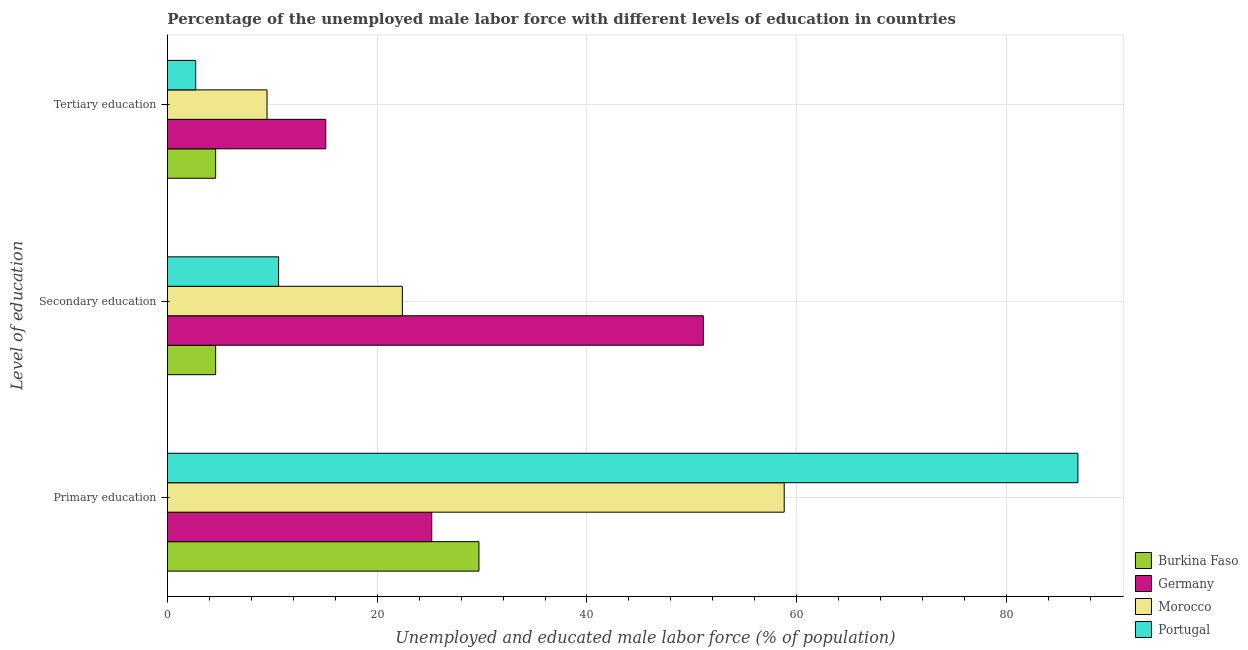How many different coloured bars are there?
Make the answer very short. 4. How many groups of bars are there?
Give a very brief answer. 3. Are the number of bars per tick equal to the number of legend labels?
Your response must be concise. Yes. How many bars are there on the 3rd tick from the top?
Your response must be concise. 4. How many bars are there on the 3rd tick from the bottom?
Your answer should be very brief. 4. What is the label of the 1st group of bars from the top?
Keep it short and to the point. Tertiary education. What is the percentage of male labor force who received tertiary education in Germany?
Provide a succinct answer. 15.1. Across all countries, what is the maximum percentage of male labor force who received primary education?
Make the answer very short. 86.8. Across all countries, what is the minimum percentage of male labor force who received secondary education?
Make the answer very short. 4.6. What is the total percentage of male labor force who received primary education in the graph?
Make the answer very short. 200.5. What is the difference between the percentage of male labor force who received secondary education in Burkina Faso and that in Portugal?
Make the answer very short. -6. What is the difference between the percentage of male labor force who received primary education in Germany and the percentage of male labor force who received secondary education in Burkina Faso?
Provide a short and direct response. 20.6. What is the average percentage of male labor force who received secondary education per country?
Provide a short and direct response. 22.17. What is the difference between the percentage of male labor force who received secondary education and percentage of male labor force who received primary education in Portugal?
Give a very brief answer. -76.2. In how many countries, is the percentage of male labor force who received primary education greater than 12 %?
Your answer should be very brief. 4. What is the ratio of the percentage of male labor force who received tertiary education in Portugal to that in Burkina Faso?
Offer a terse response. 0.59. What is the difference between the highest and the second highest percentage of male labor force who received tertiary education?
Offer a very short reply. 5.6. What is the difference between the highest and the lowest percentage of male labor force who received tertiary education?
Offer a terse response. 12.4. Is the sum of the percentage of male labor force who received secondary education in Burkina Faso and Morocco greater than the maximum percentage of male labor force who received tertiary education across all countries?
Your answer should be compact. Yes. What does the 1st bar from the bottom in Tertiary education represents?
Offer a very short reply. Burkina Faso. How many bars are there?
Make the answer very short. 12. How many countries are there in the graph?
Offer a terse response. 4. What is the difference between two consecutive major ticks on the X-axis?
Provide a short and direct response. 20. Where does the legend appear in the graph?
Offer a very short reply. Bottom right. How many legend labels are there?
Give a very brief answer. 4. What is the title of the graph?
Provide a short and direct response. Percentage of the unemployed male labor force with different levels of education in countries. What is the label or title of the X-axis?
Your response must be concise. Unemployed and educated male labor force (% of population). What is the label or title of the Y-axis?
Offer a very short reply. Level of education. What is the Unemployed and educated male labor force (% of population) in Burkina Faso in Primary education?
Offer a very short reply. 29.7. What is the Unemployed and educated male labor force (% of population) in Germany in Primary education?
Offer a terse response. 25.2. What is the Unemployed and educated male labor force (% of population) of Morocco in Primary education?
Give a very brief answer. 58.8. What is the Unemployed and educated male labor force (% of population) of Portugal in Primary education?
Offer a terse response. 86.8. What is the Unemployed and educated male labor force (% of population) of Burkina Faso in Secondary education?
Keep it short and to the point. 4.6. What is the Unemployed and educated male labor force (% of population) in Germany in Secondary education?
Ensure brevity in your answer.  51.1. What is the Unemployed and educated male labor force (% of population) in Morocco in Secondary education?
Make the answer very short. 22.4. What is the Unemployed and educated male labor force (% of population) in Portugal in Secondary education?
Give a very brief answer. 10.6. What is the Unemployed and educated male labor force (% of population) in Burkina Faso in Tertiary education?
Ensure brevity in your answer.  4.6. What is the Unemployed and educated male labor force (% of population) of Germany in Tertiary education?
Your answer should be compact. 15.1. What is the Unemployed and educated male labor force (% of population) of Portugal in Tertiary education?
Your response must be concise. 2.7. Across all Level of education, what is the maximum Unemployed and educated male labor force (% of population) in Burkina Faso?
Provide a succinct answer. 29.7. Across all Level of education, what is the maximum Unemployed and educated male labor force (% of population) of Germany?
Keep it short and to the point. 51.1. Across all Level of education, what is the maximum Unemployed and educated male labor force (% of population) of Morocco?
Your response must be concise. 58.8. Across all Level of education, what is the maximum Unemployed and educated male labor force (% of population) in Portugal?
Offer a very short reply. 86.8. Across all Level of education, what is the minimum Unemployed and educated male labor force (% of population) in Burkina Faso?
Your answer should be compact. 4.6. Across all Level of education, what is the minimum Unemployed and educated male labor force (% of population) in Germany?
Your answer should be compact. 15.1. Across all Level of education, what is the minimum Unemployed and educated male labor force (% of population) of Portugal?
Give a very brief answer. 2.7. What is the total Unemployed and educated male labor force (% of population) in Burkina Faso in the graph?
Keep it short and to the point. 38.9. What is the total Unemployed and educated male labor force (% of population) in Germany in the graph?
Your answer should be very brief. 91.4. What is the total Unemployed and educated male labor force (% of population) in Morocco in the graph?
Offer a very short reply. 90.7. What is the total Unemployed and educated male labor force (% of population) of Portugal in the graph?
Your response must be concise. 100.1. What is the difference between the Unemployed and educated male labor force (% of population) of Burkina Faso in Primary education and that in Secondary education?
Ensure brevity in your answer.  25.1. What is the difference between the Unemployed and educated male labor force (% of population) in Germany in Primary education and that in Secondary education?
Offer a very short reply. -25.9. What is the difference between the Unemployed and educated male labor force (% of population) of Morocco in Primary education and that in Secondary education?
Make the answer very short. 36.4. What is the difference between the Unemployed and educated male labor force (% of population) of Portugal in Primary education and that in Secondary education?
Offer a terse response. 76.2. What is the difference between the Unemployed and educated male labor force (% of population) of Burkina Faso in Primary education and that in Tertiary education?
Ensure brevity in your answer.  25.1. What is the difference between the Unemployed and educated male labor force (% of population) of Morocco in Primary education and that in Tertiary education?
Offer a terse response. 49.3. What is the difference between the Unemployed and educated male labor force (% of population) of Portugal in Primary education and that in Tertiary education?
Your answer should be very brief. 84.1. What is the difference between the Unemployed and educated male labor force (% of population) of Germany in Secondary education and that in Tertiary education?
Make the answer very short. 36. What is the difference between the Unemployed and educated male labor force (% of population) of Morocco in Secondary education and that in Tertiary education?
Make the answer very short. 12.9. What is the difference between the Unemployed and educated male labor force (% of population) in Portugal in Secondary education and that in Tertiary education?
Keep it short and to the point. 7.9. What is the difference between the Unemployed and educated male labor force (% of population) in Burkina Faso in Primary education and the Unemployed and educated male labor force (% of population) in Germany in Secondary education?
Your response must be concise. -21.4. What is the difference between the Unemployed and educated male labor force (% of population) of Burkina Faso in Primary education and the Unemployed and educated male labor force (% of population) of Portugal in Secondary education?
Keep it short and to the point. 19.1. What is the difference between the Unemployed and educated male labor force (% of population) of Germany in Primary education and the Unemployed and educated male labor force (% of population) of Morocco in Secondary education?
Give a very brief answer. 2.8. What is the difference between the Unemployed and educated male labor force (% of population) of Germany in Primary education and the Unemployed and educated male labor force (% of population) of Portugal in Secondary education?
Provide a succinct answer. 14.6. What is the difference between the Unemployed and educated male labor force (% of population) of Morocco in Primary education and the Unemployed and educated male labor force (% of population) of Portugal in Secondary education?
Provide a short and direct response. 48.2. What is the difference between the Unemployed and educated male labor force (% of population) of Burkina Faso in Primary education and the Unemployed and educated male labor force (% of population) of Morocco in Tertiary education?
Your response must be concise. 20.2. What is the difference between the Unemployed and educated male labor force (% of population) in Germany in Primary education and the Unemployed and educated male labor force (% of population) in Morocco in Tertiary education?
Provide a succinct answer. 15.7. What is the difference between the Unemployed and educated male labor force (% of population) of Germany in Primary education and the Unemployed and educated male labor force (% of population) of Portugal in Tertiary education?
Provide a short and direct response. 22.5. What is the difference between the Unemployed and educated male labor force (% of population) of Morocco in Primary education and the Unemployed and educated male labor force (% of population) of Portugal in Tertiary education?
Keep it short and to the point. 56.1. What is the difference between the Unemployed and educated male labor force (% of population) of Burkina Faso in Secondary education and the Unemployed and educated male labor force (% of population) of Germany in Tertiary education?
Make the answer very short. -10.5. What is the difference between the Unemployed and educated male labor force (% of population) in Germany in Secondary education and the Unemployed and educated male labor force (% of population) in Morocco in Tertiary education?
Make the answer very short. 41.6. What is the difference between the Unemployed and educated male labor force (% of population) of Germany in Secondary education and the Unemployed and educated male labor force (% of population) of Portugal in Tertiary education?
Keep it short and to the point. 48.4. What is the average Unemployed and educated male labor force (% of population) of Burkina Faso per Level of education?
Offer a very short reply. 12.97. What is the average Unemployed and educated male labor force (% of population) in Germany per Level of education?
Keep it short and to the point. 30.47. What is the average Unemployed and educated male labor force (% of population) of Morocco per Level of education?
Provide a short and direct response. 30.23. What is the average Unemployed and educated male labor force (% of population) in Portugal per Level of education?
Offer a terse response. 33.37. What is the difference between the Unemployed and educated male labor force (% of population) in Burkina Faso and Unemployed and educated male labor force (% of population) in Germany in Primary education?
Give a very brief answer. 4.5. What is the difference between the Unemployed and educated male labor force (% of population) in Burkina Faso and Unemployed and educated male labor force (% of population) in Morocco in Primary education?
Keep it short and to the point. -29.1. What is the difference between the Unemployed and educated male labor force (% of population) of Burkina Faso and Unemployed and educated male labor force (% of population) of Portugal in Primary education?
Your answer should be very brief. -57.1. What is the difference between the Unemployed and educated male labor force (% of population) of Germany and Unemployed and educated male labor force (% of population) of Morocco in Primary education?
Make the answer very short. -33.6. What is the difference between the Unemployed and educated male labor force (% of population) in Germany and Unemployed and educated male labor force (% of population) in Portugal in Primary education?
Offer a terse response. -61.6. What is the difference between the Unemployed and educated male labor force (% of population) in Burkina Faso and Unemployed and educated male labor force (% of population) in Germany in Secondary education?
Offer a very short reply. -46.5. What is the difference between the Unemployed and educated male labor force (% of population) in Burkina Faso and Unemployed and educated male labor force (% of population) in Morocco in Secondary education?
Provide a succinct answer. -17.8. What is the difference between the Unemployed and educated male labor force (% of population) in Germany and Unemployed and educated male labor force (% of population) in Morocco in Secondary education?
Provide a short and direct response. 28.7. What is the difference between the Unemployed and educated male labor force (% of population) in Germany and Unemployed and educated male labor force (% of population) in Portugal in Secondary education?
Offer a terse response. 40.5. What is the difference between the Unemployed and educated male labor force (% of population) of Morocco and Unemployed and educated male labor force (% of population) of Portugal in Secondary education?
Ensure brevity in your answer.  11.8. What is the difference between the Unemployed and educated male labor force (% of population) in Burkina Faso and Unemployed and educated male labor force (% of population) in Germany in Tertiary education?
Ensure brevity in your answer.  -10.5. What is the difference between the Unemployed and educated male labor force (% of population) in Burkina Faso and Unemployed and educated male labor force (% of population) in Portugal in Tertiary education?
Provide a succinct answer. 1.9. What is the difference between the Unemployed and educated male labor force (% of population) of Germany and Unemployed and educated male labor force (% of population) of Morocco in Tertiary education?
Offer a very short reply. 5.6. What is the ratio of the Unemployed and educated male labor force (% of population) in Burkina Faso in Primary education to that in Secondary education?
Ensure brevity in your answer.  6.46. What is the ratio of the Unemployed and educated male labor force (% of population) in Germany in Primary education to that in Secondary education?
Ensure brevity in your answer.  0.49. What is the ratio of the Unemployed and educated male labor force (% of population) in Morocco in Primary education to that in Secondary education?
Ensure brevity in your answer.  2.62. What is the ratio of the Unemployed and educated male labor force (% of population) in Portugal in Primary education to that in Secondary education?
Make the answer very short. 8.19. What is the ratio of the Unemployed and educated male labor force (% of population) of Burkina Faso in Primary education to that in Tertiary education?
Offer a very short reply. 6.46. What is the ratio of the Unemployed and educated male labor force (% of population) of Germany in Primary education to that in Tertiary education?
Give a very brief answer. 1.67. What is the ratio of the Unemployed and educated male labor force (% of population) of Morocco in Primary education to that in Tertiary education?
Provide a short and direct response. 6.19. What is the ratio of the Unemployed and educated male labor force (% of population) of Portugal in Primary education to that in Tertiary education?
Ensure brevity in your answer.  32.15. What is the ratio of the Unemployed and educated male labor force (% of population) in Burkina Faso in Secondary education to that in Tertiary education?
Your answer should be very brief. 1. What is the ratio of the Unemployed and educated male labor force (% of population) in Germany in Secondary education to that in Tertiary education?
Your answer should be very brief. 3.38. What is the ratio of the Unemployed and educated male labor force (% of population) of Morocco in Secondary education to that in Tertiary education?
Make the answer very short. 2.36. What is the ratio of the Unemployed and educated male labor force (% of population) of Portugal in Secondary education to that in Tertiary education?
Ensure brevity in your answer.  3.93. What is the difference between the highest and the second highest Unemployed and educated male labor force (% of population) of Burkina Faso?
Your answer should be very brief. 25.1. What is the difference between the highest and the second highest Unemployed and educated male labor force (% of population) in Germany?
Provide a succinct answer. 25.9. What is the difference between the highest and the second highest Unemployed and educated male labor force (% of population) in Morocco?
Ensure brevity in your answer.  36.4. What is the difference between the highest and the second highest Unemployed and educated male labor force (% of population) of Portugal?
Give a very brief answer. 76.2. What is the difference between the highest and the lowest Unemployed and educated male labor force (% of population) of Burkina Faso?
Your response must be concise. 25.1. What is the difference between the highest and the lowest Unemployed and educated male labor force (% of population) of Morocco?
Keep it short and to the point. 49.3. What is the difference between the highest and the lowest Unemployed and educated male labor force (% of population) in Portugal?
Give a very brief answer. 84.1. 